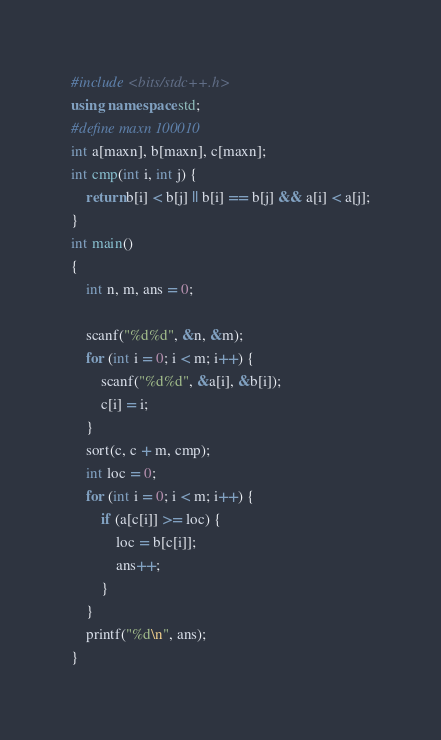<code> <loc_0><loc_0><loc_500><loc_500><_C++_>#include <bits/stdc++.h>
using namespace std;
#define maxn 100010
int a[maxn], b[maxn], c[maxn];
int cmp(int i, int j) {
	return b[i] < b[j] || b[i] == b[j] && a[i] < a[j];
}
int main()
{
	int n, m, ans = 0;
	
	scanf("%d%d", &n, &m);
	for (int i = 0; i < m; i++) {
		scanf("%d%d", &a[i], &b[i]);
		c[i] = i;
	}
	sort(c, c + m, cmp);
	int loc = 0;
	for (int i = 0; i < m; i++) {
		if (a[c[i]] >= loc) {
			loc = b[c[i]];
			ans++;
		}
	}
	printf("%d\n", ans);
}
</code> 